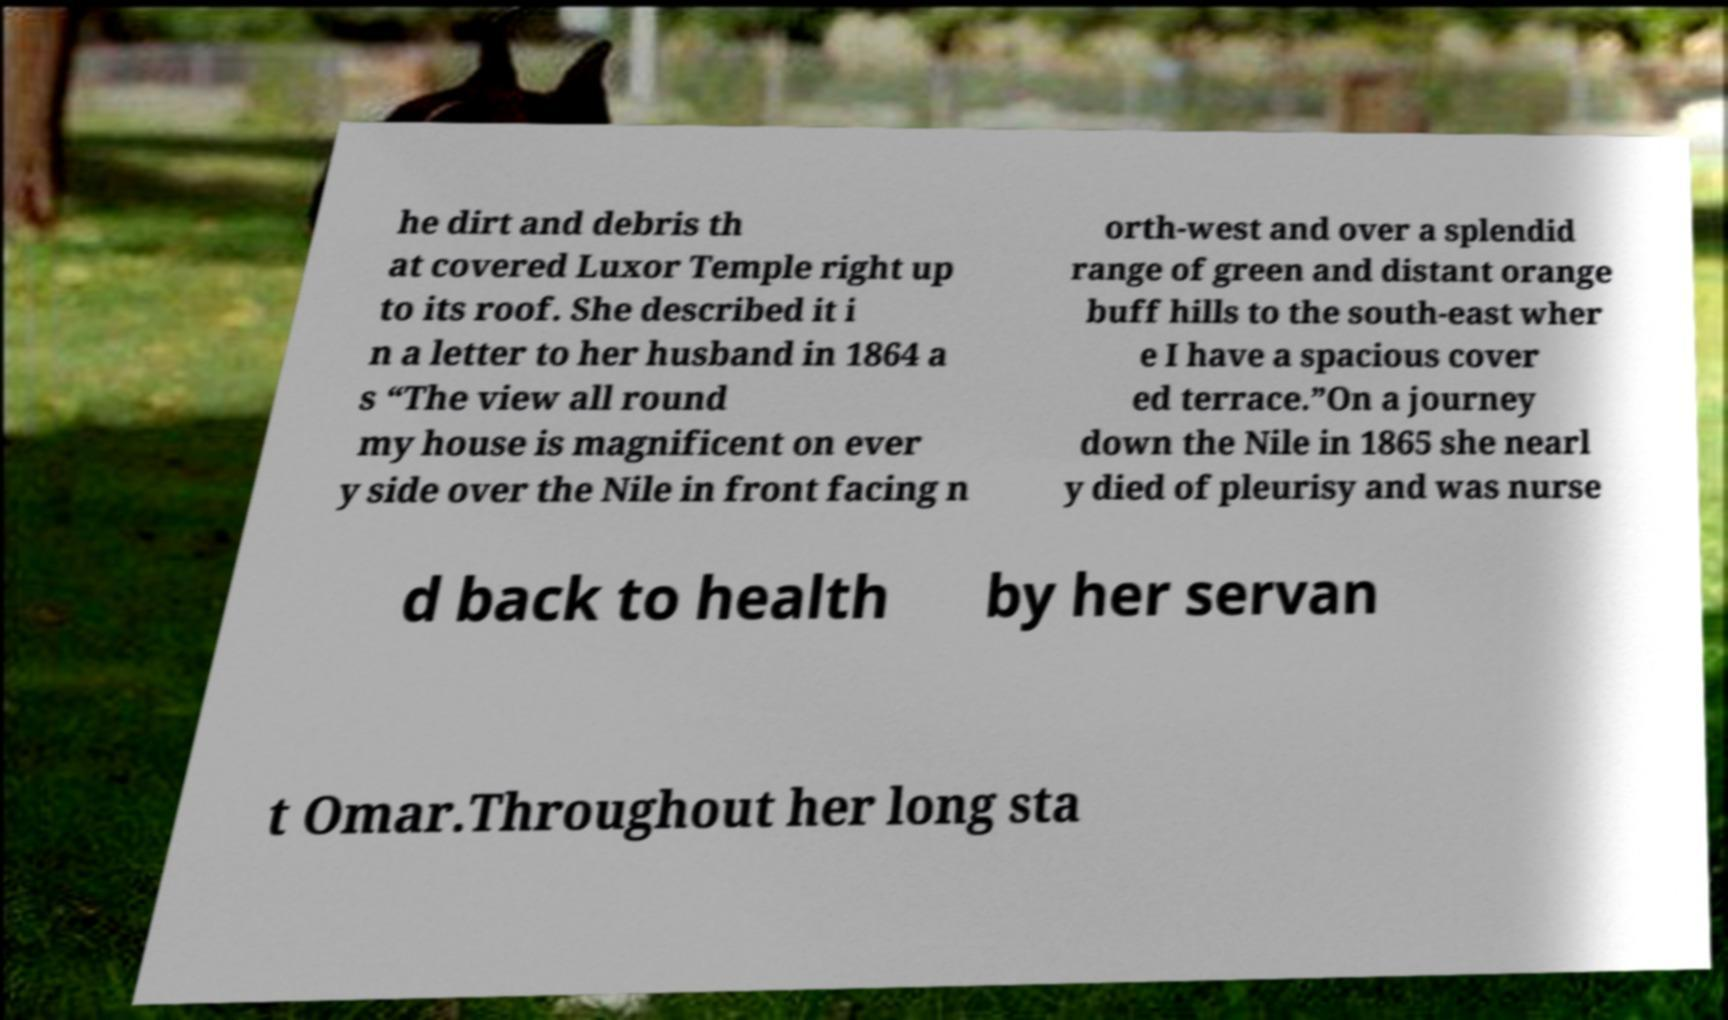Could you assist in decoding the text presented in this image and type it out clearly? he dirt and debris th at covered Luxor Temple right up to its roof. She described it i n a letter to her husband in 1864 a s “The view all round my house is magnificent on ever y side over the Nile in front facing n orth-west and over a splendid range of green and distant orange buff hills to the south-east wher e I have a spacious cover ed terrace.”On a journey down the Nile in 1865 she nearl y died of pleurisy and was nurse d back to health by her servan t Omar.Throughout her long sta 